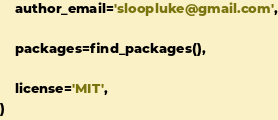<code> <loc_0><loc_0><loc_500><loc_500><_Python_>    author_email='sloopluke@gmail.com',

    packages=find_packages(),

    license='MIT',
)
</code> 